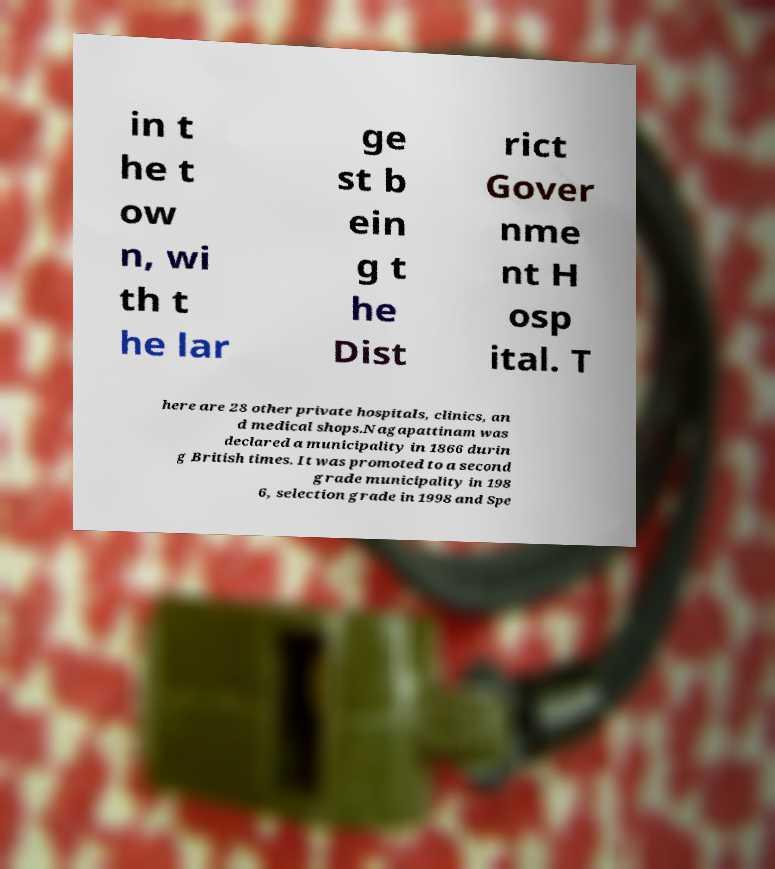There's text embedded in this image that I need extracted. Can you transcribe it verbatim? in t he t ow n, wi th t he lar ge st b ein g t he Dist rict Gover nme nt H osp ital. T here are 28 other private hospitals, clinics, an d medical shops.Nagapattinam was declared a municipality in 1866 durin g British times. It was promoted to a second grade municipality in 198 6, selection grade in 1998 and Spe 